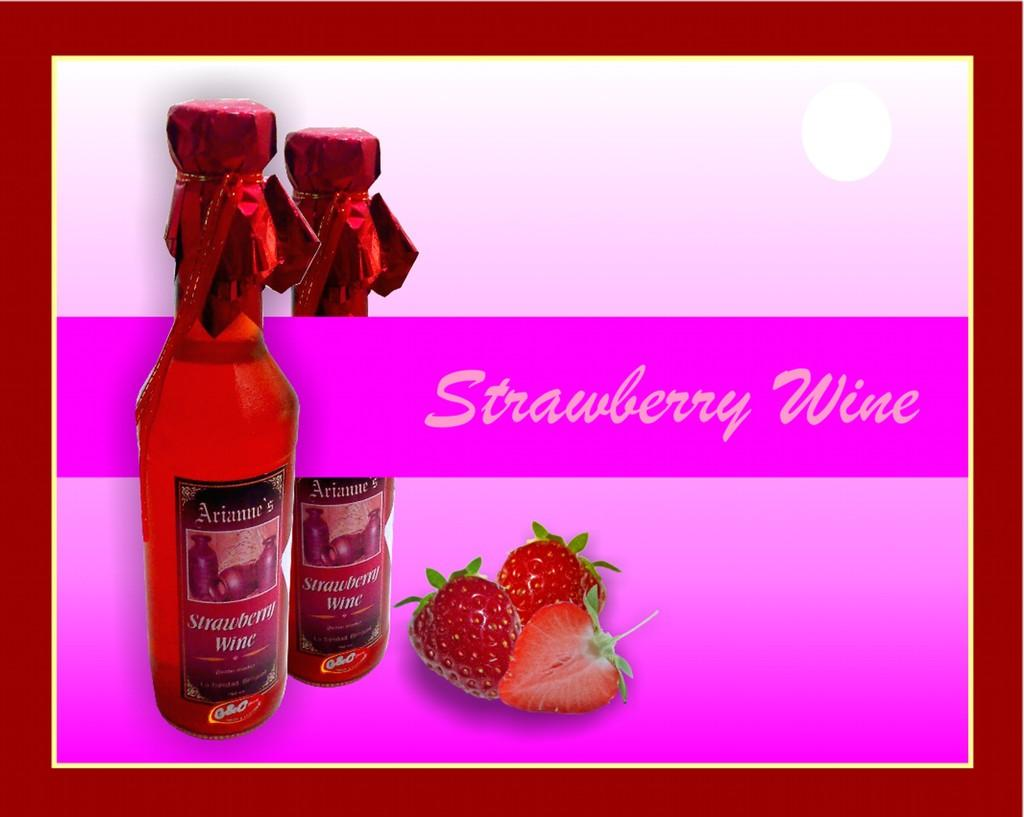What type of visual is the image? The image is a poster. What objects are depicted in the poster? There are pictures of bottles and strawberries in the poster. Is there any text present on the poster? Yes, there is text on the poster. What color is the button on the poster? There is no button present on the poster. Which company is featured on the poster? The provided facts do not mention any company being featured on the poster. 